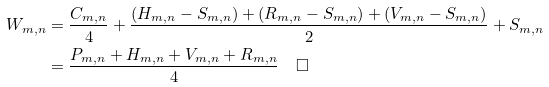Convert formula to latex. <formula><loc_0><loc_0><loc_500><loc_500>W _ { m , n } & = \frac { C _ { m , n } } { 4 } + \frac { ( H _ { m , n } - S _ { m , n } ) + ( R _ { m , n } - S _ { m , n } ) + ( V _ { m , n } - S _ { m , n } ) } { 2 } + S _ { m , n } \\ & = \frac { P _ { m , n } + H _ { m , n } + V _ { m , n } + R _ { m , n } } { 4 } \quad \Box</formula> 